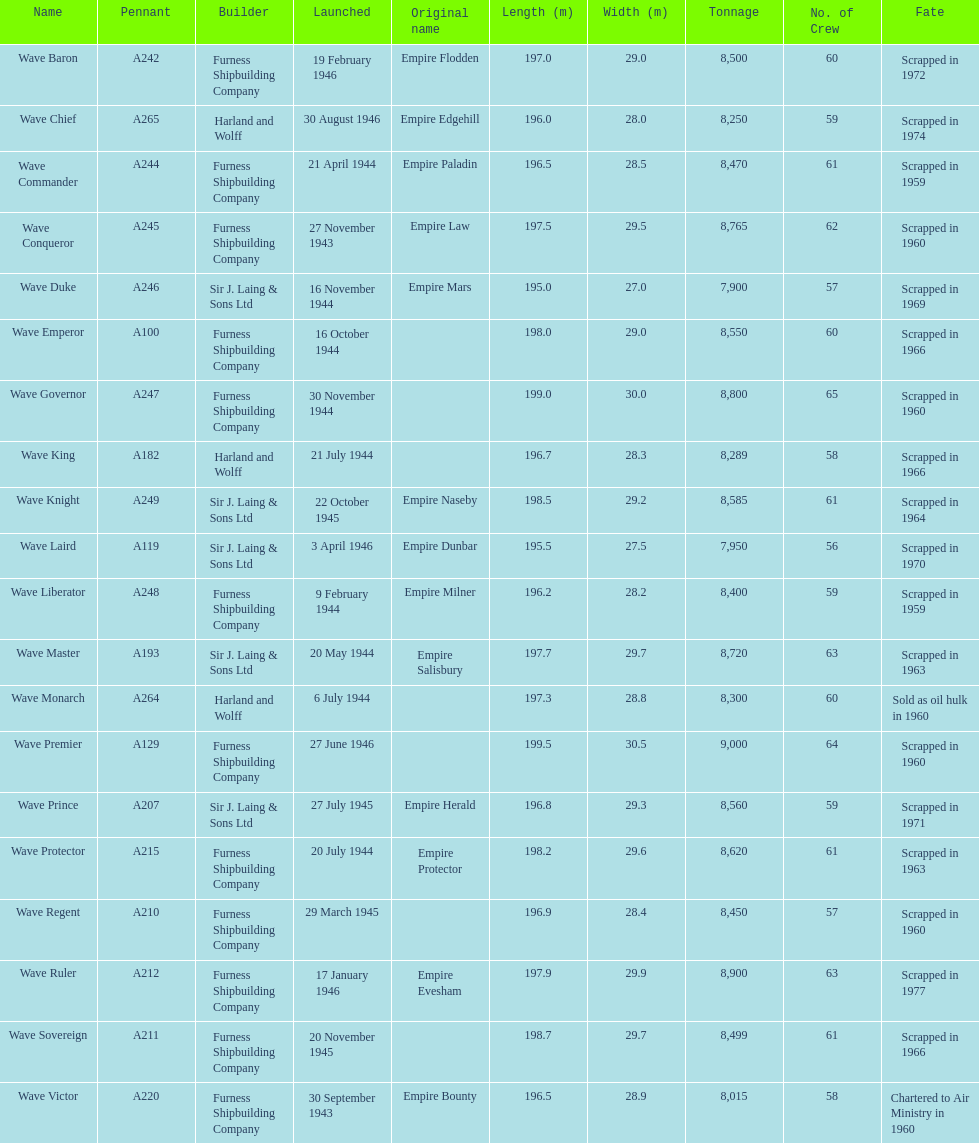Name a builder with "and" in the name. Harland and Wolff. 